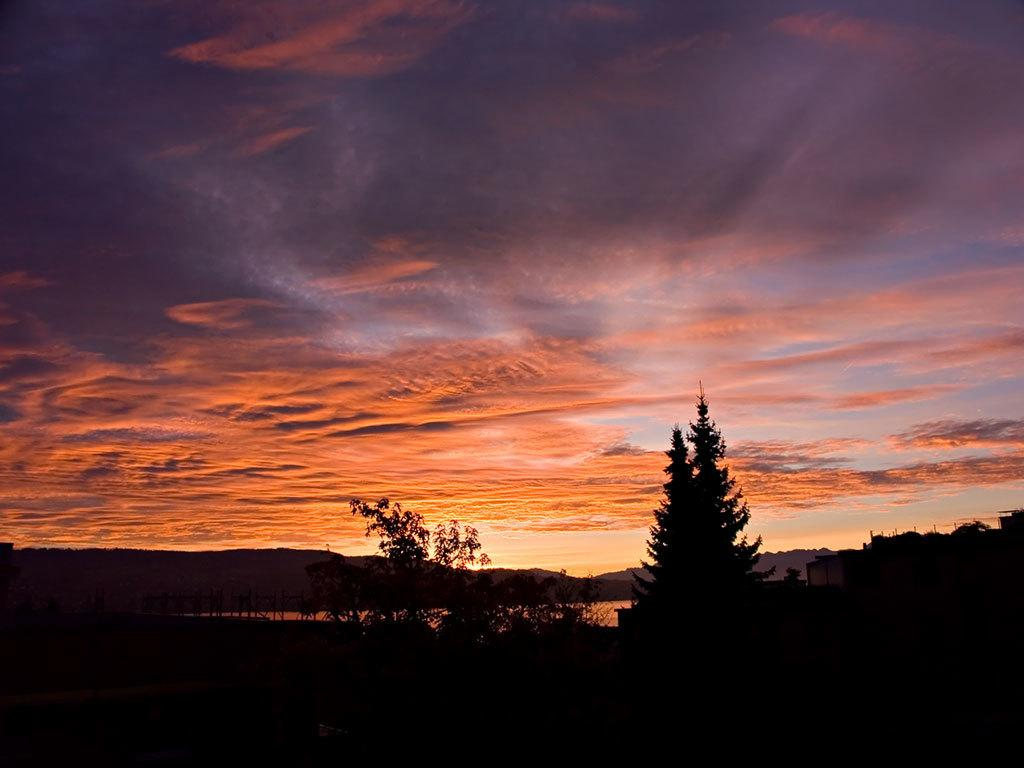What type of structure is in the picture? There is a house in the picture. Where are the trees located in relation to the house? The trees are on the left side of the house. What can be seen in front of the house? There are hills in front of the house. What part of the natural environment is visible in the picture? The sky is visible in the picture. What type of fiction is the tramp reading while sitting on the clouds in the image? There are no clouds, tramp, or any reading material present in the image. 